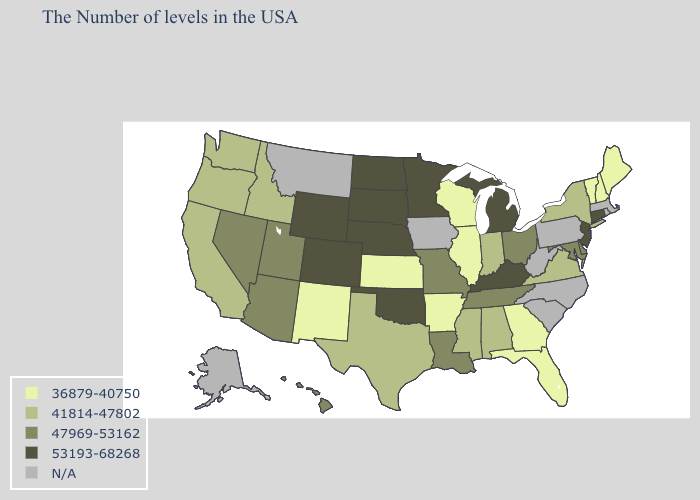What is the lowest value in states that border Mississippi?
Keep it brief. 36879-40750. What is the lowest value in the South?
Keep it brief. 36879-40750. Does Alabama have the highest value in the USA?
Write a very short answer. No. How many symbols are there in the legend?
Be succinct. 5. What is the highest value in the USA?
Be succinct. 53193-68268. Name the states that have a value in the range 53193-68268?
Keep it brief. Connecticut, New Jersey, Michigan, Kentucky, Minnesota, Nebraska, Oklahoma, South Dakota, North Dakota, Wyoming, Colorado. What is the value of Indiana?
Be succinct. 41814-47802. Name the states that have a value in the range N/A?
Answer briefly. Massachusetts, Rhode Island, Pennsylvania, North Carolina, South Carolina, West Virginia, Iowa, Montana, Alaska. Name the states that have a value in the range 47969-53162?
Be succinct. Delaware, Maryland, Ohio, Tennessee, Louisiana, Missouri, Utah, Arizona, Nevada, Hawaii. Which states have the lowest value in the South?
Concise answer only. Florida, Georgia, Arkansas. What is the highest value in the South ?
Short answer required. 53193-68268. 